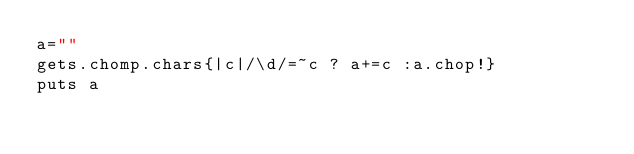Convert code to text. <code><loc_0><loc_0><loc_500><loc_500><_Ruby_>a=""
gets.chomp.chars{|c|/\d/=~c ? a+=c :a.chop!}
puts a</code> 